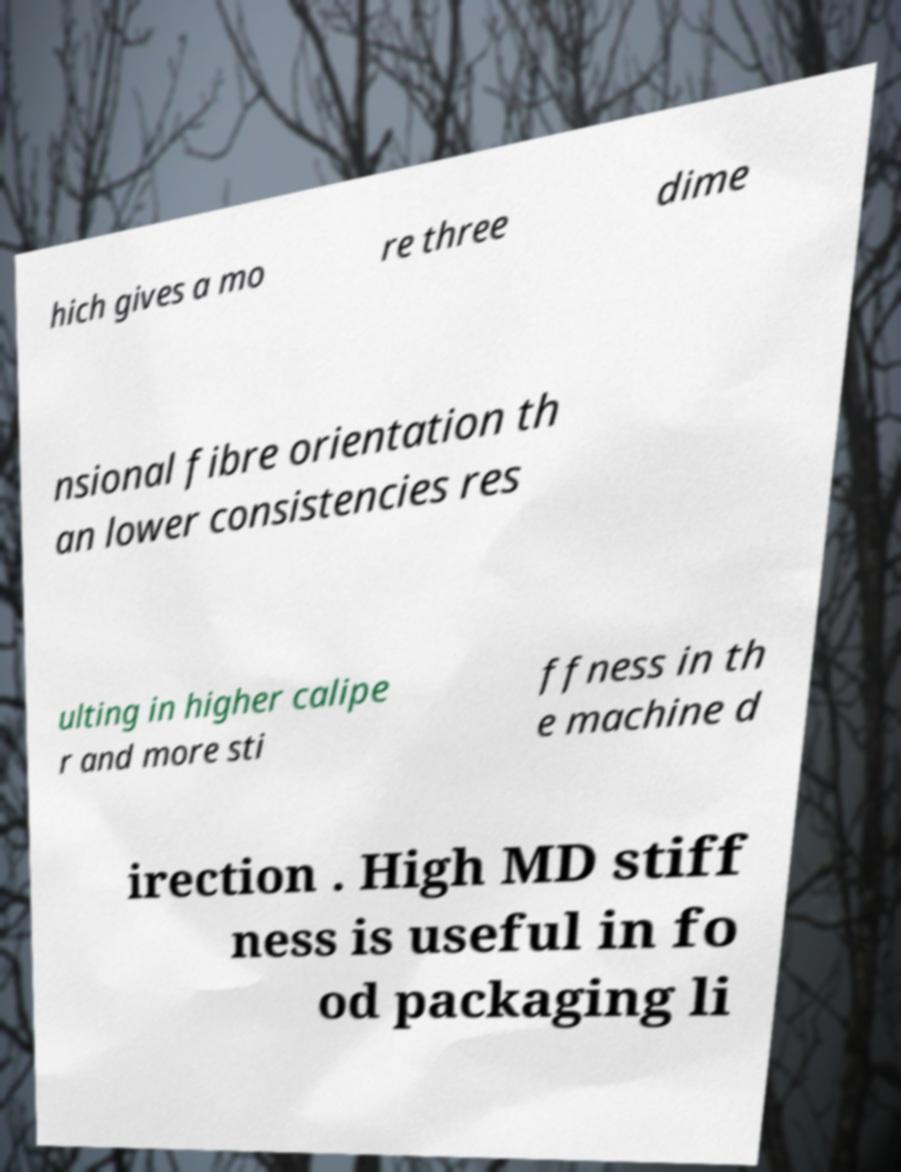Please identify and transcribe the text found in this image. hich gives a mo re three dime nsional fibre orientation th an lower consistencies res ulting in higher calipe r and more sti ffness in th e machine d irection . High MD stiff ness is useful in fo od packaging li 